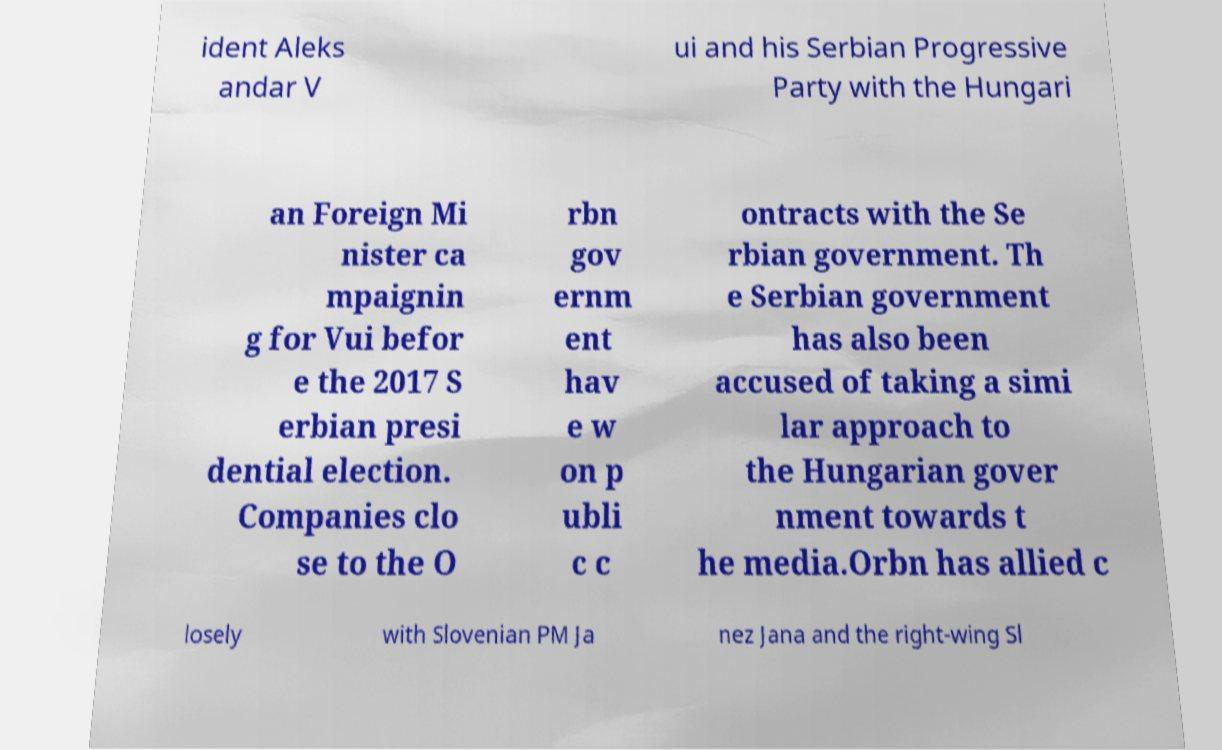For documentation purposes, I need the text within this image transcribed. Could you provide that? ident Aleks andar V ui and his Serbian Progressive Party with the Hungari an Foreign Mi nister ca mpaignin g for Vui befor e the 2017 S erbian presi dential election. Companies clo se to the O rbn gov ernm ent hav e w on p ubli c c ontracts with the Se rbian government. Th e Serbian government has also been accused of taking a simi lar approach to the Hungarian gover nment towards t he media.Orbn has allied c losely with Slovenian PM Ja nez Jana and the right-wing Sl 